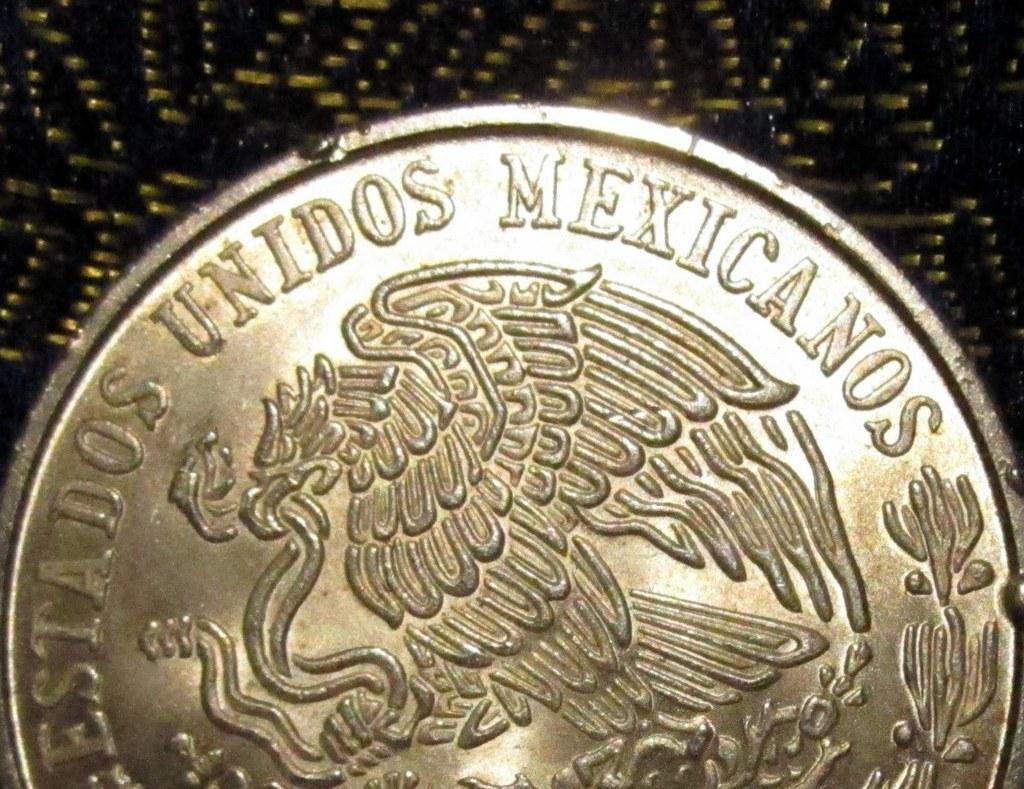Provide a one-sentence caption for the provided image. a silver coin reading Unidos Mexicanos around the edge. 